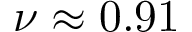Convert formula to latex. <formula><loc_0><loc_0><loc_500><loc_500>\nu \approx 0 . 9 1</formula> 